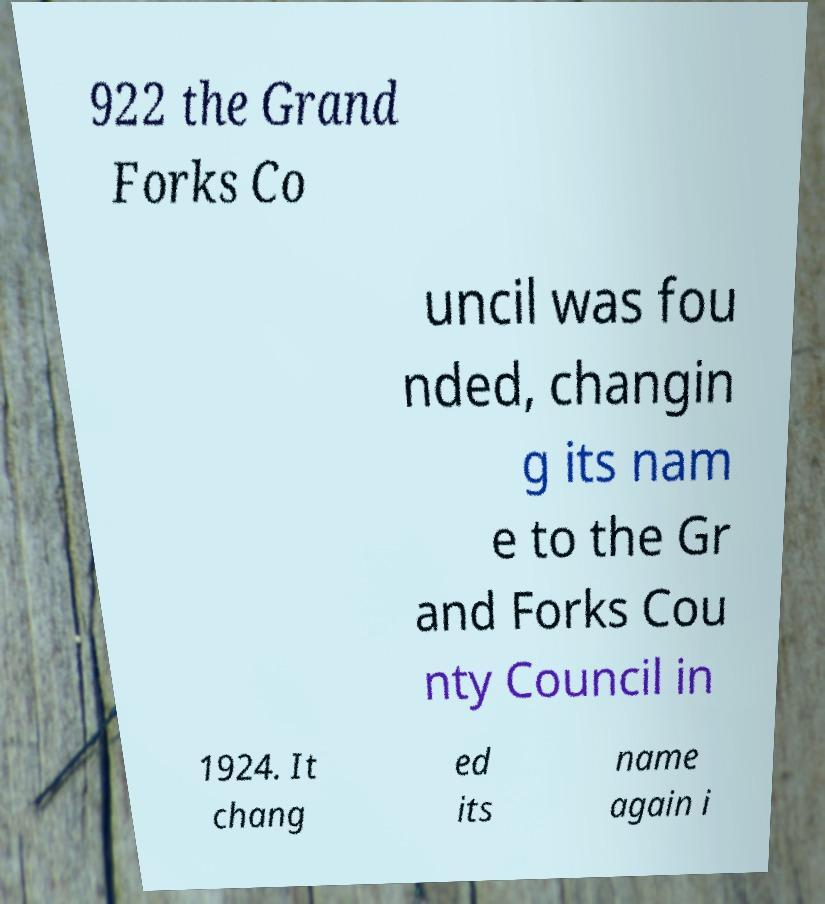Please identify and transcribe the text found in this image. 922 the Grand Forks Co uncil was fou nded, changin g its nam e to the Gr and Forks Cou nty Council in 1924. It chang ed its name again i 